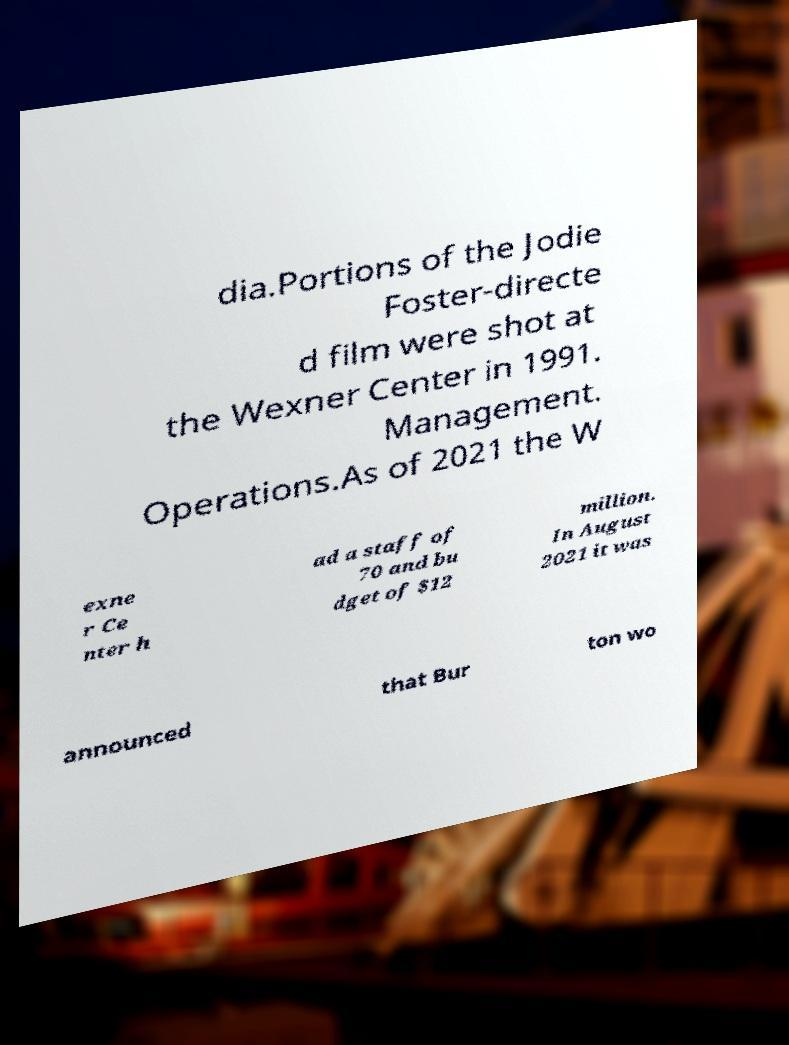Could you assist in decoding the text presented in this image and type it out clearly? dia.Portions of the Jodie Foster-directe d film were shot at the Wexner Center in 1991. Management. Operations.As of 2021 the W exne r Ce nter h ad a staff of 70 and bu dget of $12 million. In August 2021 it was announced that Bur ton wo 